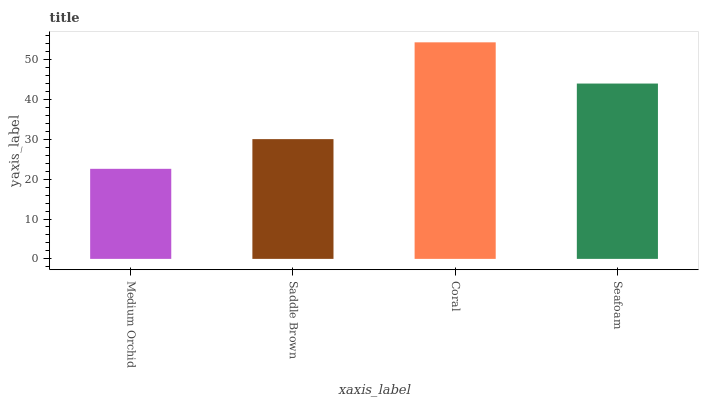Is Medium Orchid the minimum?
Answer yes or no. Yes. Is Coral the maximum?
Answer yes or no. Yes. Is Saddle Brown the minimum?
Answer yes or no. No. Is Saddle Brown the maximum?
Answer yes or no. No. Is Saddle Brown greater than Medium Orchid?
Answer yes or no. Yes. Is Medium Orchid less than Saddle Brown?
Answer yes or no. Yes. Is Medium Orchid greater than Saddle Brown?
Answer yes or no. No. Is Saddle Brown less than Medium Orchid?
Answer yes or no. No. Is Seafoam the high median?
Answer yes or no. Yes. Is Saddle Brown the low median?
Answer yes or no. Yes. Is Saddle Brown the high median?
Answer yes or no. No. Is Seafoam the low median?
Answer yes or no. No. 